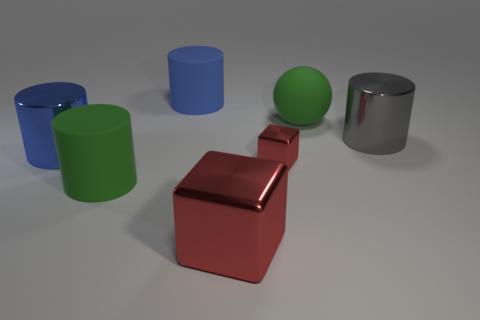The large green object that is in front of the small metal object has what shape?
Provide a short and direct response. Cylinder. What is the color of the rubber sphere that is the same size as the gray metal thing?
Keep it short and to the point. Green. Does the blue thing that is behind the blue metallic cylinder have the same material as the big sphere?
Your answer should be compact. Yes. There is a thing that is both left of the blue matte cylinder and right of the big blue metal object; what size is it?
Your response must be concise. Large. What size is the matte cylinder that is right of the big green cylinder?
Offer a terse response. Large. What shape is the other metal thing that is the same color as the small shiny thing?
Offer a terse response. Cube. There is a large matte object in front of the blue object that is in front of the blue cylinder that is to the right of the large blue metallic object; what is its shape?
Provide a short and direct response. Cylinder. How many other objects are the same shape as the gray metal thing?
Your answer should be very brief. 3. What number of shiny things are either gray things or small things?
Make the answer very short. 2. There is a green thing on the right side of the blue cylinder that is right of the green cylinder; what is its material?
Offer a terse response. Rubber. 